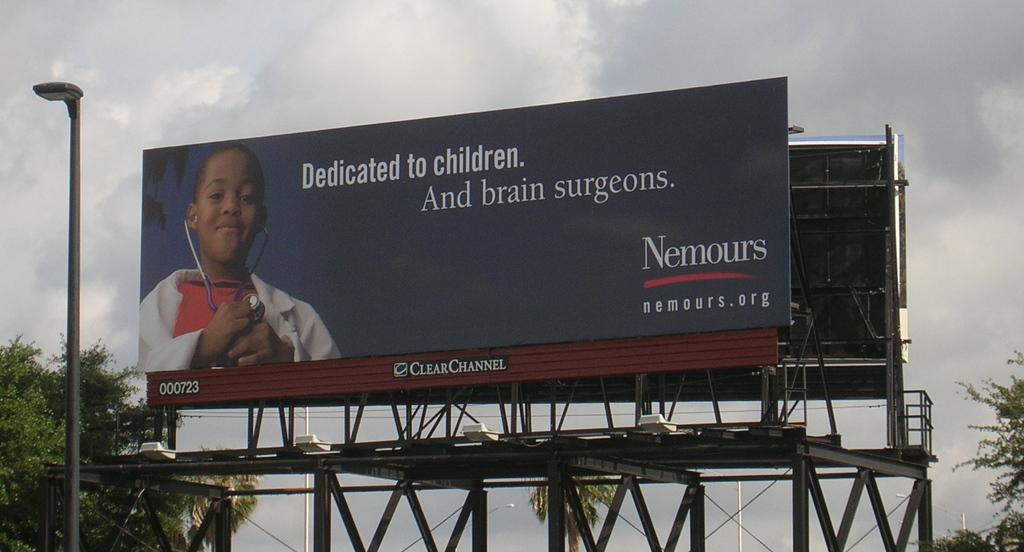<image>
Provide a brief description of the given image. A billboard for Nemours children's hospital advertises brain surgery. 